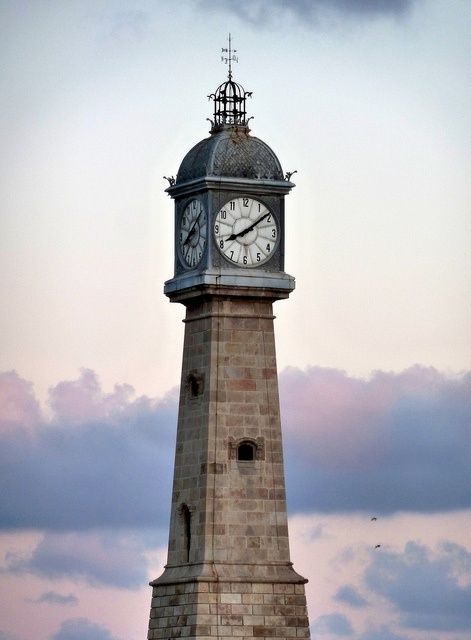Describe the objects in this image and their specific colors. I can see clock in darkgray, lightgray, gray, and black tones and clock in darkgray, gray, black, and darkblue tones in this image. 